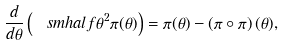<formula> <loc_0><loc_0><loc_500><loc_500>\frac { d } { d \theta } \left ( \ s m h a l f \theta ^ { 2 } \pi ( \theta ) \right ) = \pi ( \theta ) - \left ( \pi \circ \pi \right ) ( \theta ) ,</formula> 